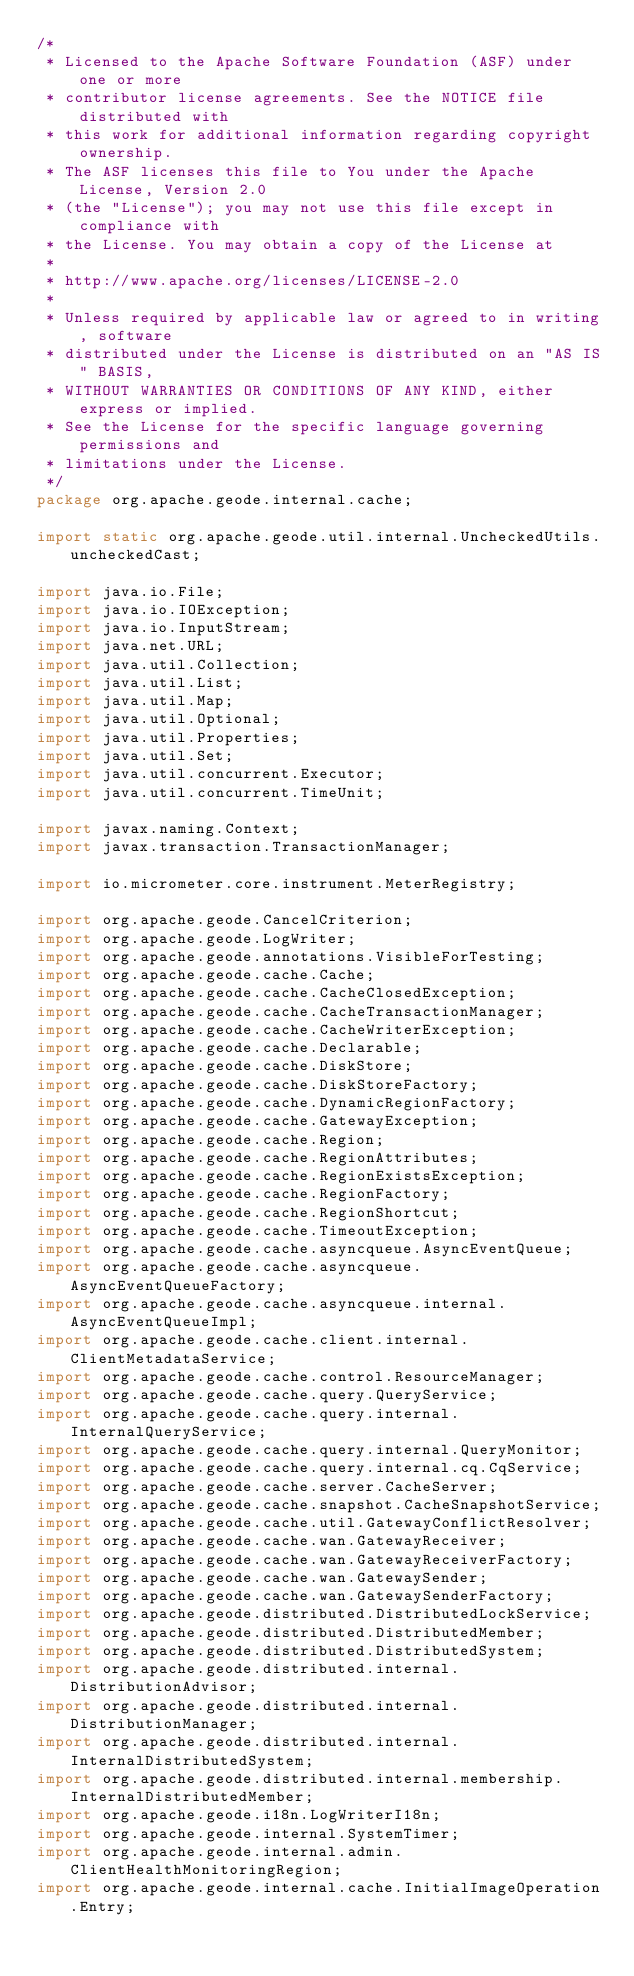<code> <loc_0><loc_0><loc_500><loc_500><_Java_>/*
 * Licensed to the Apache Software Foundation (ASF) under one or more
 * contributor license agreements. See the NOTICE file distributed with
 * this work for additional information regarding copyright ownership.
 * The ASF licenses this file to You under the Apache License, Version 2.0
 * (the "License"); you may not use this file except in compliance with
 * the License. You may obtain a copy of the License at
 *
 * http://www.apache.org/licenses/LICENSE-2.0
 *
 * Unless required by applicable law or agreed to in writing, software
 * distributed under the License is distributed on an "AS IS" BASIS,
 * WITHOUT WARRANTIES OR CONDITIONS OF ANY KIND, either express or implied.
 * See the License for the specific language governing permissions and
 * limitations under the License.
 */
package org.apache.geode.internal.cache;

import static org.apache.geode.util.internal.UncheckedUtils.uncheckedCast;

import java.io.File;
import java.io.IOException;
import java.io.InputStream;
import java.net.URL;
import java.util.Collection;
import java.util.List;
import java.util.Map;
import java.util.Optional;
import java.util.Properties;
import java.util.Set;
import java.util.concurrent.Executor;
import java.util.concurrent.TimeUnit;

import javax.naming.Context;
import javax.transaction.TransactionManager;

import io.micrometer.core.instrument.MeterRegistry;

import org.apache.geode.CancelCriterion;
import org.apache.geode.LogWriter;
import org.apache.geode.annotations.VisibleForTesting;
import org.apache.geode.cache.Cache;
import org.apache.geode.cache.CacheClosedException;
import org.apache.geode.cache.CacheTransactionManager;
import org.apache.geode.cache.CacheWriterException;
import org.apache.geode.cache.Declarable;
import org.apache.geode.cache.DiskStore;
import org.apache.geode.cache.DiskStoreFactory;
import org.apache.geode.cache.DynamicRegionFactory;
import org.apache.geode.cache.GatewayException;
import org.apache.geode.cache.Region;
import org.apache.geode.cache.RegionAttributes;
import org.apache.geode.cache.RegionExistsException;
import org.apache.geode.cache.RegionFactory;
import org.apache.geode.cache.RegionShortcut;
import org.apache.geode.cache.TimeoutException;
import org.apache.geode.cache.asyncqueue.AsyncEventQueue;
import org.apache.geode.cache.asyncqueue.AsyncEventQueueFactory;
import org.apache.geode.cache.asyncqueue.internal.AsyncEventQueueImpl;
import org.apache.geode.cache.client.internal.ClientMetadataService;
import org.apache.geode.cache.control.ResourceManager;
import org.apache.geode.cache.query.QueryService;
import org.apache.geode.cache.query.internal.InternalQueryService;
import org.apache.geode.cache.query.internal.QueryMonitor;
import org.apache.geode.cache.query.internal.cq.CqService;
import org.apache.geode.cache.server.CacheServer;
import org.apache.geode.cache.snapshot.CacheSnapshotService;
import org.apache.geode.cache.util.GatewayConflictResolver;
import org.apache.geode.cache.wan.GatewayReceiver;
import org.apache.geode.cache.wan.GatewayReceiverFactory;
import org.apache.geode.cache.wan.GatewaySender;
import org.apache.geode.cache.wan.GatewaySenderFactory;
import org.apache.geode.distributed.DistributedLockService;
import org.apache.geode.distributed.DistributedMember;
import org.apache.geode.distributed.DistributedSystem;
import org.apache.geode.distributed.internal.DistributionAdvisor;
import org.apache.geode.distributed.internal.DistributionManager;
import org.apache.geode.distributed.internal.InternalDistributedSystem;
import org.apache.geode.distributed.internal.membership.InternalDistributedMember;
import org.apache.geode.i18n.LogWriterI18n;
import org.apache.geode.internal.SystemTimer;
import org.apache.geode.internal.admin.ClientHealthMonitoringRegion;
import org.apache.geode.internal.cache.InitialImageOperation.Entry;</code> 